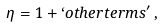Convert formula to latex. <formula><loc_0><loc_0><loc_500><loc_500>\eta = 1 + ` o t h e r t e r m s ^ { \prime } \, ,</formula> 